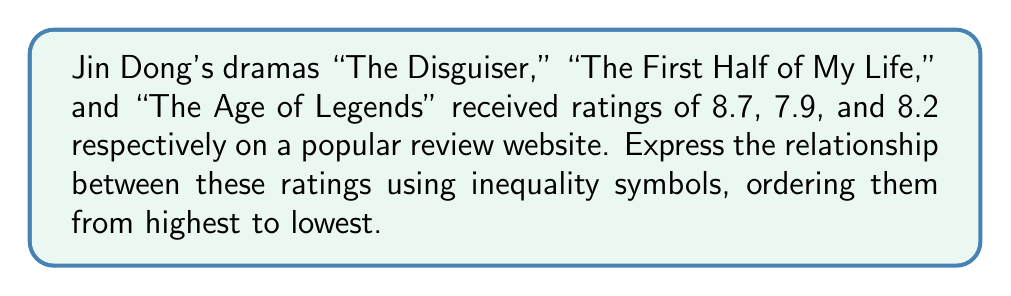Teach me how to tackle this problem. To solve this problem, we need to compare the given ratings and arrange them in descending order:

1. "The Disguiser": 8.7
2. "The Age of Legends": 8.2
3. "The First Half of My Life": 7.9

We can see that:
8.7 > 8.2 > 7.9

Now, let's assign variables to each drama:
Let $D$ = rating of "The Disguiser"
Let $A$ = rating of "The Age of Legends"
Let $F$ = rating of "The First Half of My Life"

We can express the relationship using inequality symbols as follows:

$$D > A > F$$

This inequality shows that the rating of "The Disguiser" is greater than the rating of "The Age of Legends," which is in turn greater than the rating of "The First Half of My Life."
Answer: $D > A > F$ 